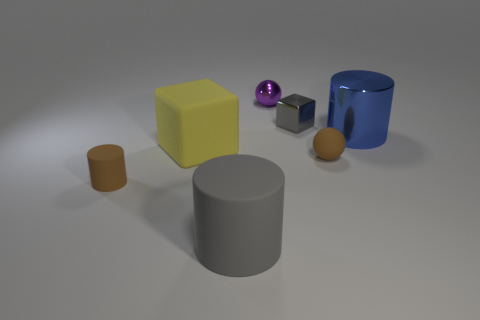There is a large rubber thing that is in front of the tiny brown cylinder; is its shape the same as the small brown object on the left side of the yellow matte object? The large rubber object you mentioned has a cylindrical shape which is similar to the tiny brown cylinder's shape. However, it's considerably larger in size. Both objects share the attribute of being elongated and round in cross-section, which categorizes them as cylinders. 